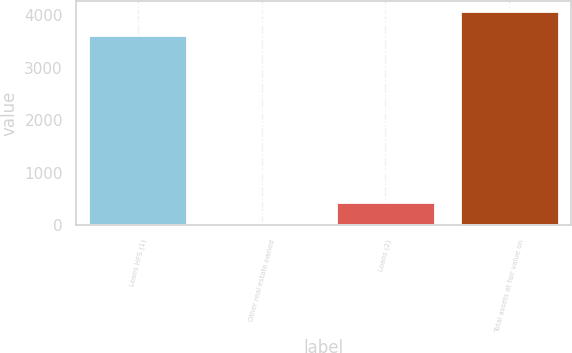Convert chart. <chart><loc_0><loc_0><loc_500><loc_500><bar_chart><fcel>Loans HFS (1)<fcel>Other real estate owned<fcel>Loans (2)<fcel>Total assets at fair value on<nl><fcel>3609<fcel>44<fcel>446.3<fcel>4067<nl></chart> 